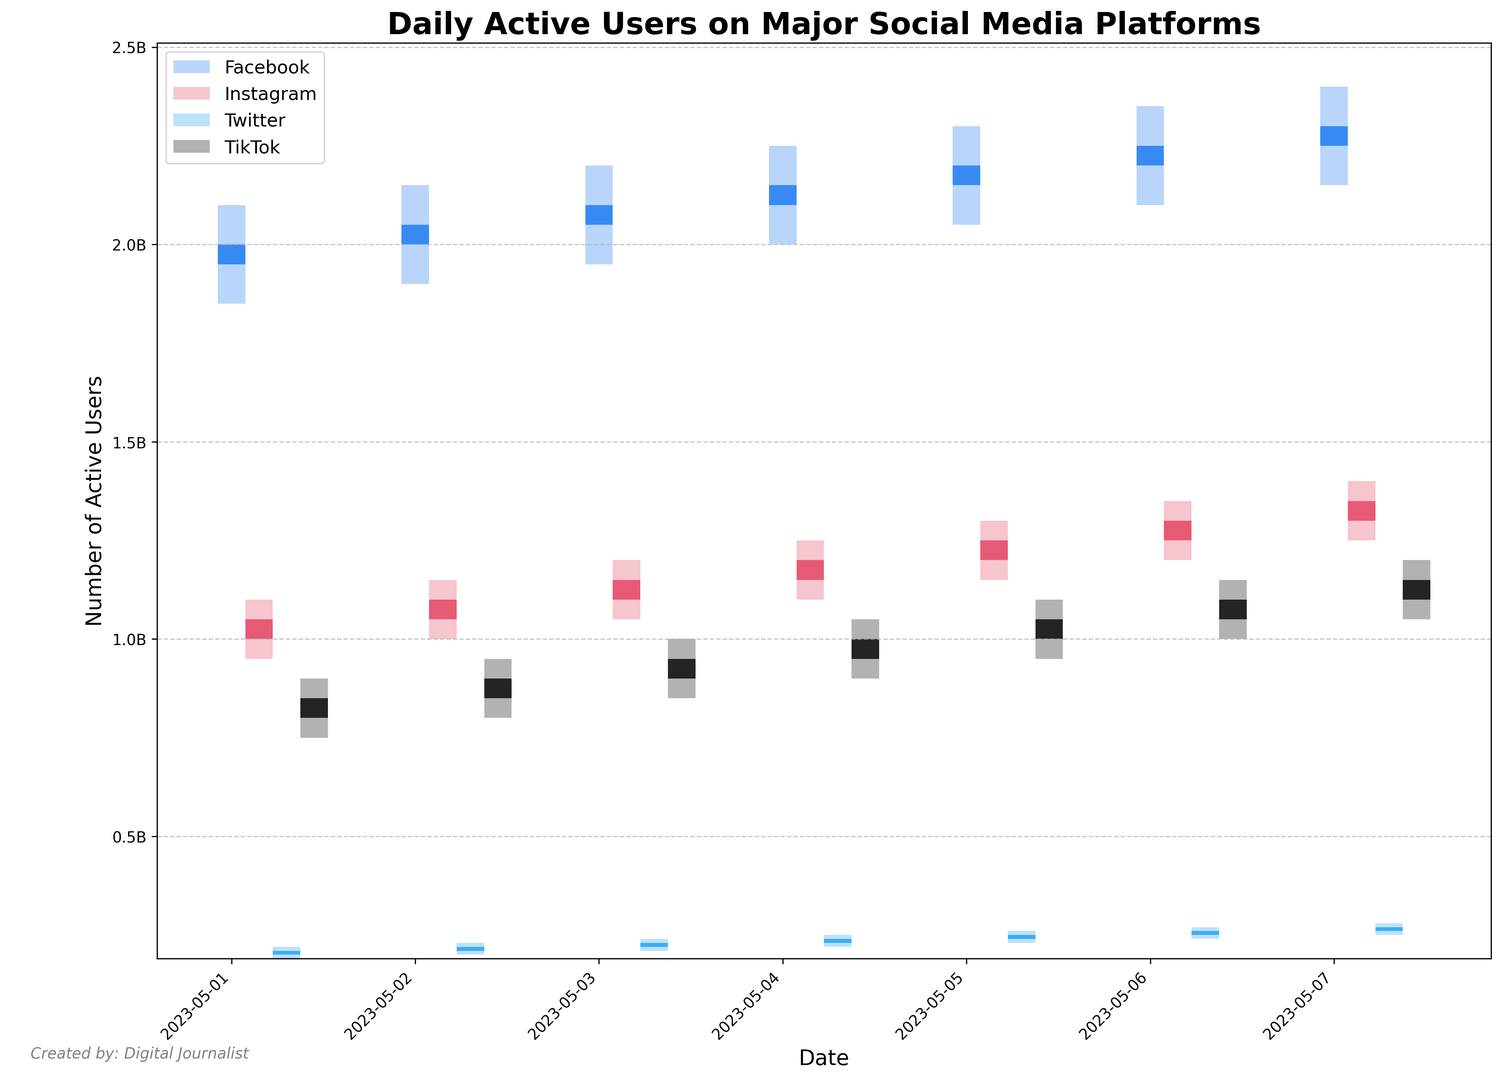What's the peak number of active users for Facebook during the week? Look for the highest point (peak) in Facebook's data. From the data, we see that Facebook hits a peak of 2400000000 users on 2023-05-07.
Answer: 2400000000 Which platform had the most significant increase in daily active users from 2023-05-01 to 2023-05-07? Calculate the difference between the closing values of 2023-05-07 and 2023-05-01 for each platform: Facebook (2300000000 - 2000000000 = 300000000), Instagram (1350000000 - 1050000000 = 300000000), Twitter (270000000 - 210000000 = 60000000), TikTok (1150000000 - 850000000 = 300000000). TikTok, Instagram, and Facebook had the same increase.
Answer: Facebook, Instagram, and TikTok On which day did Instagram have its highest daily active users? Look for the day with the highest closing value for Instagram. Instagram has its highest closing value of 1350000000 on 2023-05-07.
Answer: 2023-05-07 Between Twitter and TikTok, which platform saw a higher number of active users on 2023-05-04? Compare the closing values of Twitter and TikTok on 2023-05-04. Twitter's closing value is 240000000, while TikTok's is 1000000000. TikTok saw a higher number of active users.
Answer: TikTok What is the average closing value for Facebook over the week? Sum the closing values for each day for Facebook and divide by the number of days (2000000000 + 2050000000 + 2100000000 + 2150000000 + 2200000000 + 2250000000 + 2300000000), which equals 15000000000. Dividing by 7 gives 15000000000 / 7 ≈ 2142857143.
Answer: 2142857143 Which social media platform had the lowest number of daily active users on 2023-05-02? Identify the closed values for each platform on 2023-05-02: Facebook (2050000000), Instagram (1100000000), Twitter (220000000), TikTok (900000000). Twitter had the lowest number of daily active users.
Answer: Twitter What is the total number of active users across all platforms on 2023-05-03? Sum the closing values for each platform on 2023-05-03: Facebook (2100000000) + Instagram (1150000000) + Twitter (230000000) + TikTok (950000000), totaling 4430000000.
Answer: 4430000000 Which platform had the most fluctuation in active users on 2023-05-05? Calculate the difference between the high and low values for each platform on 2023-05-05: Facebook (2300000000 - 2050000000 = 250000000), Instagram (1300000000 - 1150000000 = 150000000), Twitter (260000000 - 230000000 = 30000000), TikTok (1100000000 - 950000000 = 150000000). Facebook had the most fluctuation.
Answer: Facebook 